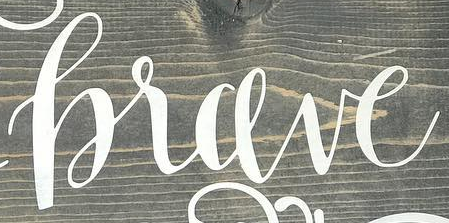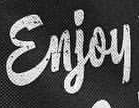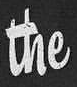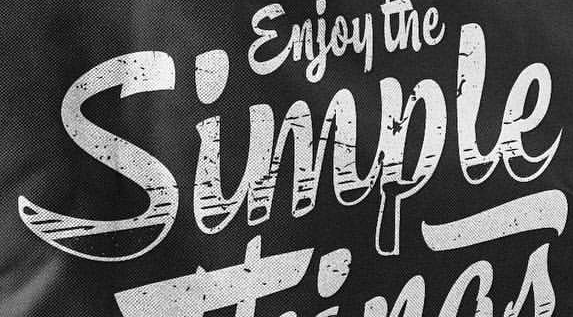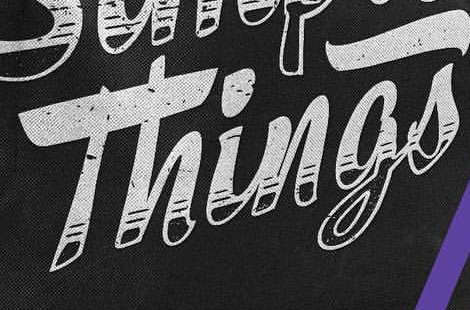What words can you see in these images in sequence, separated by a semicolon? hrave; Enjoy; the; Simple; Things 